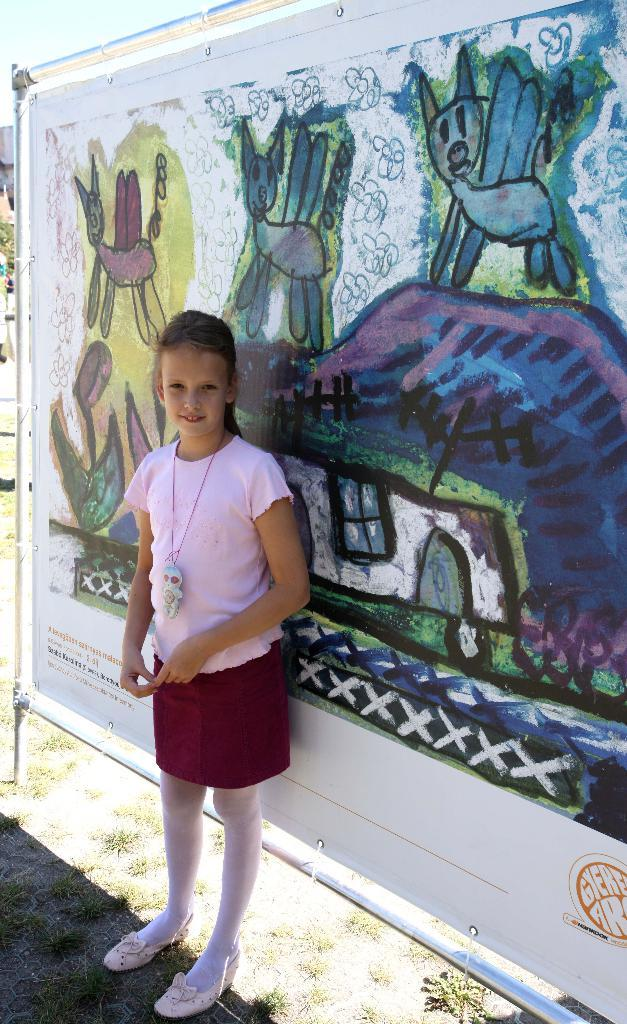What is the main subject of the image? There is a girl standing in the image. What is the girl's position in relation to the ground? The girl is standing on the ground. What is the girl's facial expression? The girl is smiling. What type of vegetation is visible in the image? There is grass visible in the image. What can be seen in the background of the image? There is a painting on a banner and rods visible in the background. What type of coat is the girl wearing in the image? The image does not show the girl wearing a coat. What type of trade is being conducted in the image? There is no trade being conducted in the image; it features a girl standing and smiling. 